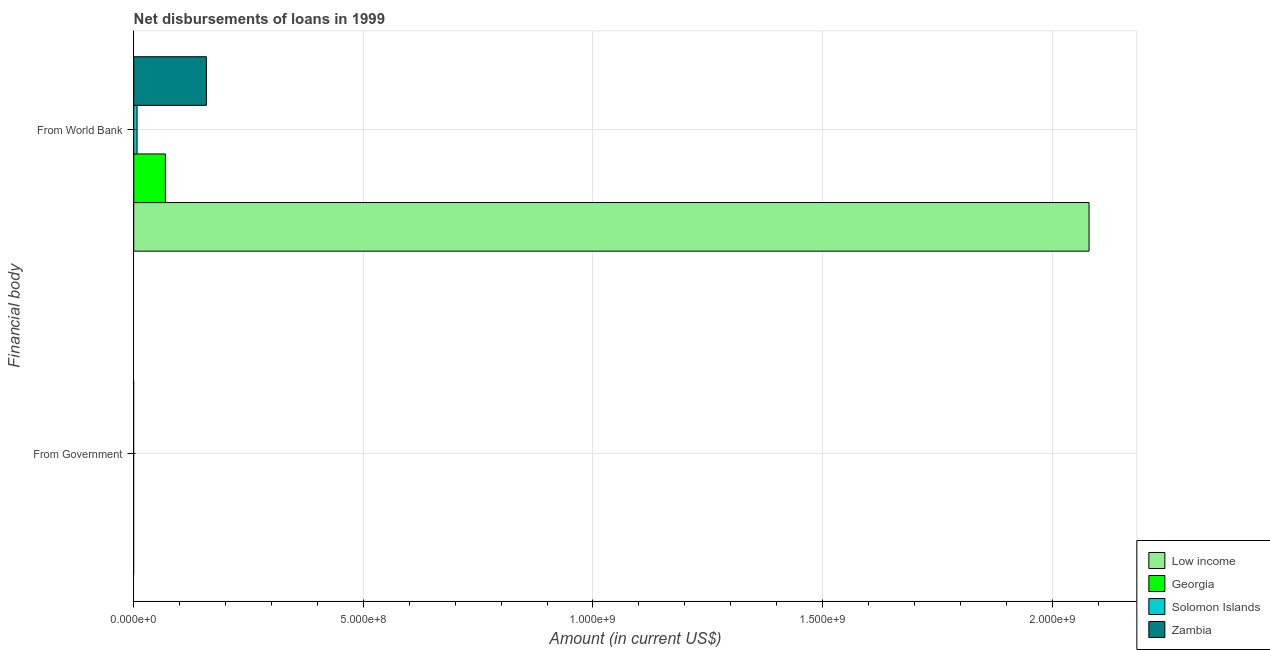Are the number of bars per tick equal to the number of legend labels?
Give a very brief answer. No. Are the number of bars on each tick of the Y-axis equal?
Provide a succinct answer. No. How many bars are there on the 2nd tick from the top?
Ensure brevity in your answer.  0. What is the label of the 1st group of bars from the top?
Provide a succinct answer. From World Bank. What is the net disbursements of loan from world bank in Solomon Islands?
Your answer should be compact. 7.23e+06. Across all countries, what is the maximum net disbursements of loan from world bank?
Ensure brevity in your answer.  2.08e+09. Across all countries, what is the minimum net disbursements of loan from government?
Your response must be concise. 0. In which country was the net disbursements of loan from world bank maximum?
Provide a succinct answer. Low income. What is the total net disbursements of loan from government in the graph?
Ensure brevity in your answer.  0. What is the difference between the net disbursements of loan from world bank in Low income and that in Zambia?
Provide a short and direct response. 1.92e+09. What is the difference between the net disbursements of loan from government in Low income and the net disbursements of loan from world bank in Georgia?
Your answer should be compact. -6.89e+07. What is the average net disbursements of loan from world bank per country?
Your response must be concise. 5.79e+08. What is the ratio of the net disbursements of loan from world bank in Georgia to that in Zambia?
Offer a terse response. 0.44. Is the net disbursements of loan from world bank in Solomon Islands less than that in Georgia?
Give a very brief answer. Yes. In how many countries, is the net disbursements of loan from world bank greater than the average net disbursements of loan from world bank taken over all countries?
Provide a succinct answer. 1. How many bars are there?
Your answer should be very brief. 4. How many countries are there in the graph?
Your response must be concise. 4. What is the difference between two consecutive major ticks on the X-axis?
Provide a succinct answer. 5.00e+08. Are the values on the major ticks of X-axis written in scientific E-notation?
Offer a terse response. Yes. Does the graph contain any zero values?
Offer a terse response. Yes. Does the graph contain grids?
Your answer should be very brief. Yes. Where does the legend appear in the graph?
Keep it short and to the point. Bottom right. How many legend labels are there?
Make the answer very short. 4. What is the title of the graph?
Give a very brief answer. Net disbursements of loans in 1999. Does "Caribbean small states" appear as one of the legend labels in the graph?
Offer a very short reply. No. What is the label or title of the Y-axis?
Provide a short and direct response. Financial body. What is the Amount (in current US$) of Georgia in From Government?
Your answer should be very brief. 0. What is the Amount (in current US$) in Solomon Islands in From Government?
Your response must be concise. 0. What is the Amount (in current US$) in Low income in From World Bank?
Offer a very short reply. 2.08e+09. What is the Amount (in current US$) of Georgia in From World Bank?
Provide a short and direct response. 6.89e+07. What is the Amount (in current US$) of Solomon Islands in From World Bank?
Ensure brevity in your answer.  7.23e+06. What is the Amount (in current US$) of Zambia in From World Bank?
Provide a short and direct response. 1.58e+08. Across all Financial body, what is the maximum Amount (in current US$) in Low income?
Your answer should be compact. 2.08e+09. Across all Financial body, what is the maximum Amount (in current US$) of Georgia?
Offer a terse response. 6.89e+07. Across all Financial body, what is the maximum Amount (in current US$) in Solomon Islands?
Offer a very short reply. 7.23e+06. Across all Financial body, what is the maximum Amount (in current US$) in Zambia?
Provide a succinct answer. 1.58e+08. Across all Financial body, what is the minimum Amount (in current US$) of Georgia?
Make the answer very short. 0. What is the total Amount (in current US$) in Low income in the graph?
Offer a terse response. 2.08e+09. What is the total Amount (in current US$) in Georgia in the graph?
Ensure brevity in your answer.  6.89e+07. What is the total Amount (in current US$) of Solomon Islands in the graph?
Provide a short and direct response. 7.23e+06. What is the total Amount (in current US$) of Zambia in the graph?
Your answer should be compact. 1.58e+08. What is the average Amount (in current US$) of Low income per Financial body?
Provide a succinct answer. 1.04e+09. What is the average Amount (in current US$) of Georgia per Financial body?
Keep it short and to the point. 3.45e+07. What is the average Amount (in current US$) of Solomon Islands per Financial body?
Provide a succinct answer. 3.62e+06. What is the average Amount (in current US$) of Zambia per Financial body?
Your answer should be compact. 7.91e+07. What is the difference between the Amount (in current US$) of Low income and Amount (in current US$) of Georgia in From World Bank?
Provide a short and direct response. 2.01e+09. What is the difference between the Amount (in current US$) in Low income and Amount (in current US$) in Solomon Islands in From World Bank?
Offer a very short reply. 2.07e+09. What is the difference between the Amount (in current US$) of Low income and Amount (in current US$) of Zambia in From World Bank?
Provide a short and direct response. 1.92e+09. What is the difference between the Amount (in current US$) in Georgia and Amount (in current US$) in Solomon Islands in From World Bank?
Your answer should be very brief. 6.17e+07. What is the difference between the Amount (in current US$) of Georgia and Amount (in current US$) of Zambia in From World Bank?
Offer a very short reply. -8.93e+07. What is the difference between the Amount (in current US$) of Solomon Islands and Amount (in current US$) of Zambia in From World Bank?
Make the answer very short. -1.51e+08. What is the difference between the highest and the lowest Amount (in current US$) of Low income?
Give a very brief answer. 2.08e+09. What is the difference between the highest and the lowest Amount (in current US$) of Georgia?
Ensure brevity in your answer.  6.89e+07. What is the difference between the highest and the lowest Amount (in current US$) of Solomon Islands?
Make the answer very short. 7.23e+06. What is the difference between the highest and the lowest Amount (in current US$) of Zambia?
Ensure brevity in your answer.  1.58e+08. 